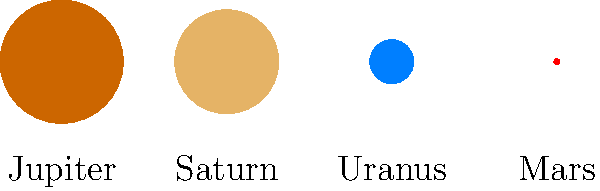As you consider expanding your hardware store's inventory to include telescopes and astronomy-related products, you come across this diagram showing the relative sizes of four planets in our solar system. Based on the image, which planet is approximately 18 times larger in diameter than Mars? To solve this problem, let's follow these steps:

1. Identify the planets: The diagram shows Jupiter, Saturn, Uranus, and Mars (from left to right).

2. Compare sizes: We need to find a planet that's about 18 times larger in diameter than Mars.

3. Calculate the ratio:
   Let's compare each planet's diameter to Mars:
   
   Jupiter/Mars = 11.2 / 0.53 ≈ 21.13
   Saturn/Mars = 9.45 / 0.53 ≈ 17.83
   Uranus/Mars = 4.0 / 0.53 ≈ 7.55

4. Analyze results:
   Jupiter is about 21 times larger than Mars
   Saturn is about 18 times larger than Mars
   Uranus is about 7.5 times larger than Mars

5. Conclusion: Saturn is the closest to being 18 times larger than Mars in diameter.

This knowledge can be useful when explaining the scale of planets to customers interested in astronomy products, helping them understand the vast differences in size within our solar system.
Answer: Saturn 